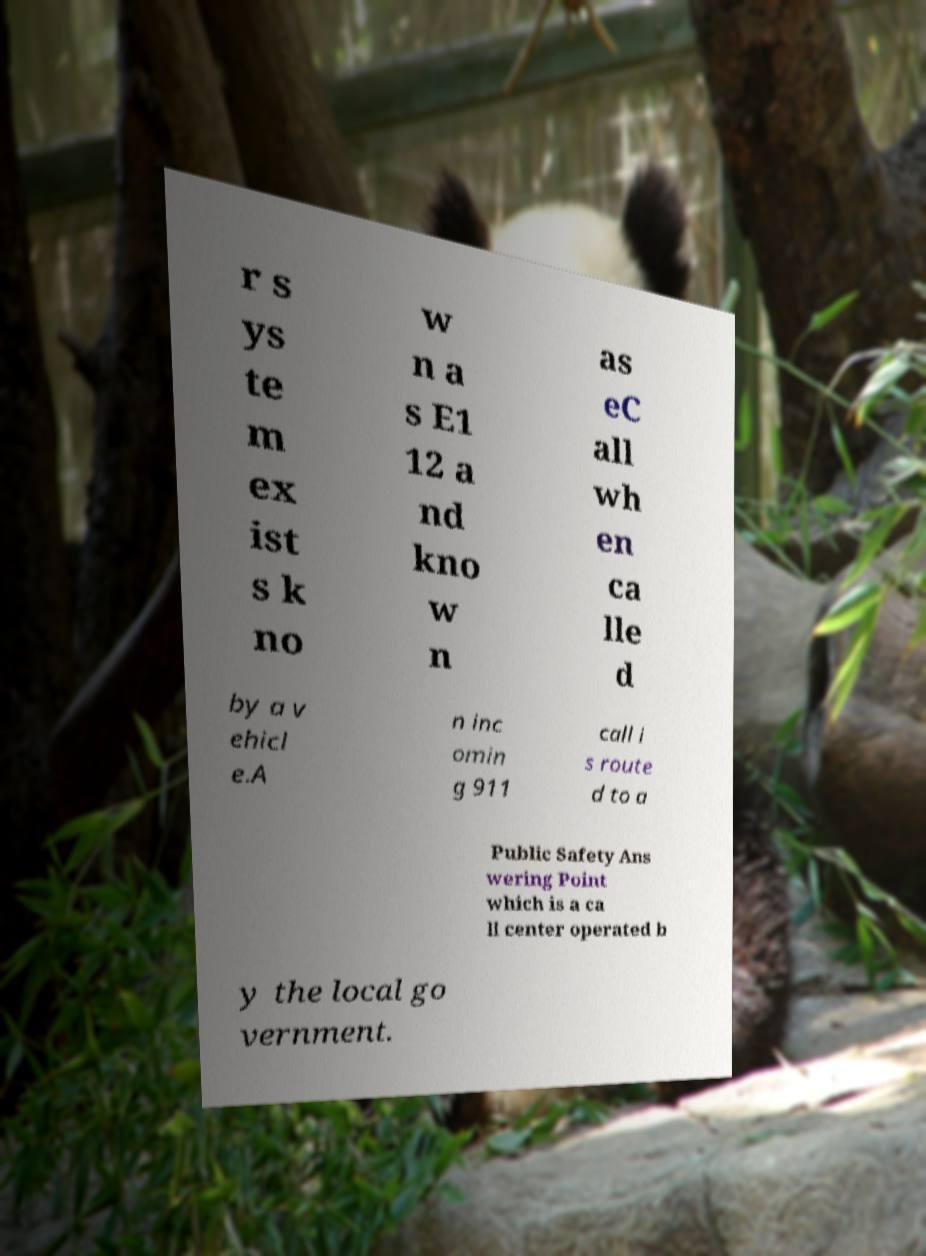Can you accurately transcribe the text from the provided image for me? r s ys te m ex ist s k no w n a s E1 12 a nd kno w n as eC all wh en ca lle d by a v ehicl e.A n inc omin g 911 call i s route d to a Public Safety Ans wering Point which is a ca ll center operated b y the local go vernment. 